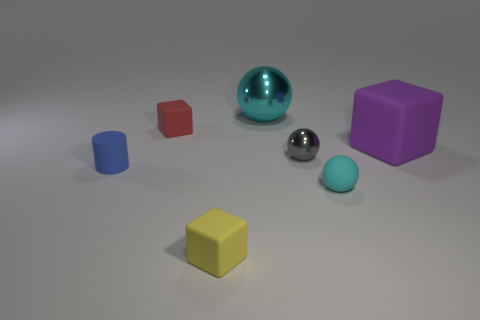Add 3 cyan rubber spheres. How many objects exist? 10 Subtract all cylinders. How many objects are left? 6 Subtract all big green shiny cylinders. Subtract all blue rubber cylinders. How many objects are left? 6 Add 5 tiny blue cylinders. How many tiny blue cylinders are left? 6 Add 1 large yellow cylinders. How many large yellow cylinders exist? 1 Subtract 1 blue cylinders. How many objects are left? 6 